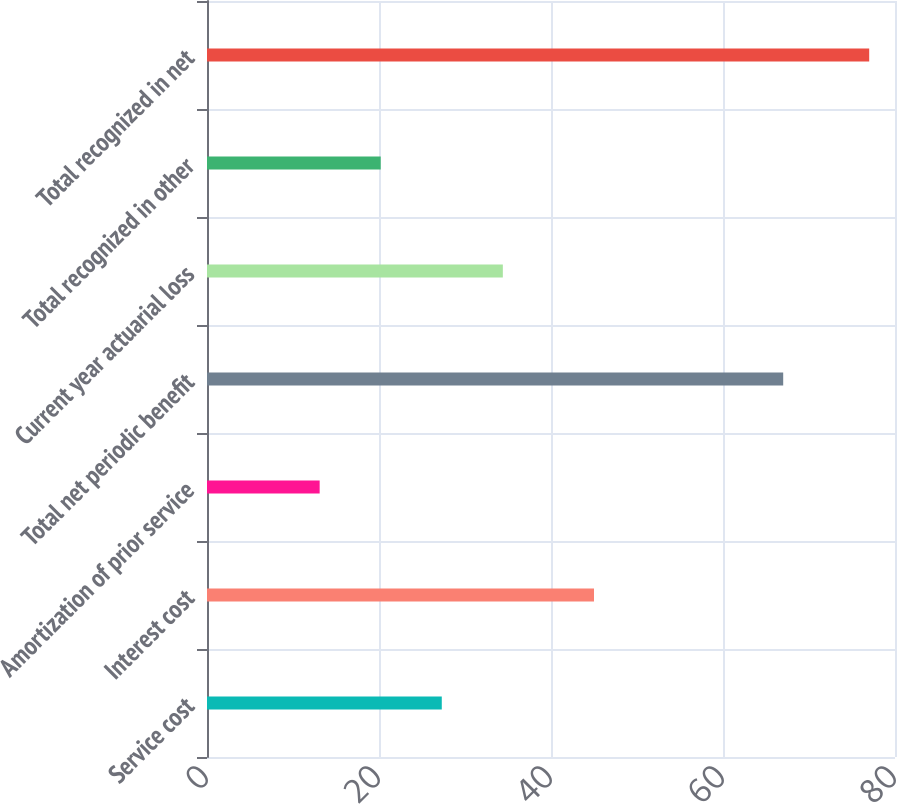Convert chart. <chart><loc_0><loc_0><loc_500><loc_500><bar_chart><fcel>Service cost<fcel>Interest cost<fcel>Amortization of prior service<fcel>Total net periodic benefit<fcel>Current year actuarial loss<fcel>Total recognized in other<fcel>Total recognized in net<nl><fcel>27.3<fcel>45<fcel>13.1<fcel>67<fcel>34.4<fcel>20.2<fcel>77<nl></chart> 